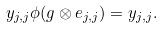<formula> <loc_0><loc_0><loc_500><loc_500>y _ { j , j } \phi ( g \otimes e _ { j , j } ) = y _ { j , j } .</formula> 